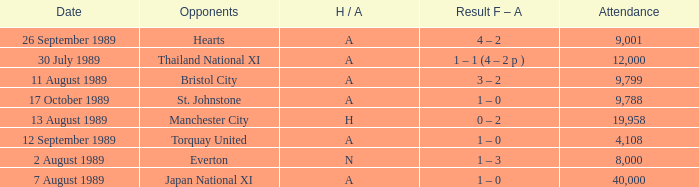When did Manchester United play against Bristol City with an H/A of A? 11 August 1989. 